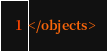<code> <loc_0><loc_0><loc_500><loc_500><_XML_></objects>
</code> 